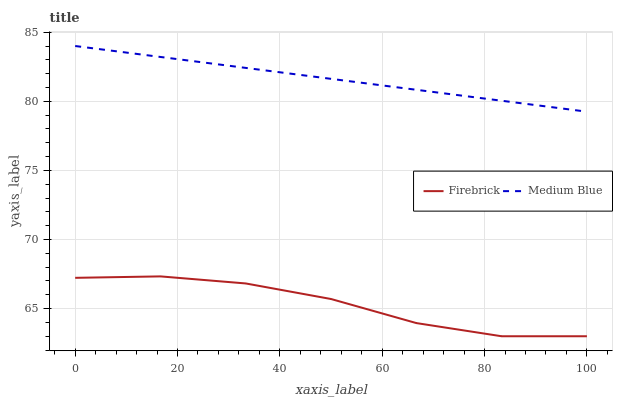Does Medium Blue have the minimum area under the curve?
Answer yes or no. No. Is Medium Blue the roughest?
Answer yes or no. No. Does Medium Blue have the lowest value?
Answer yes or no. No. Is Firebrick less than Medium Blue?
Answer yes or no. Yes. Is Medium Blue greater than Firebrick?
Answer yes or no. Yes. Does Firebrick intersect Medium Blue?
Answer yes or no. No. 